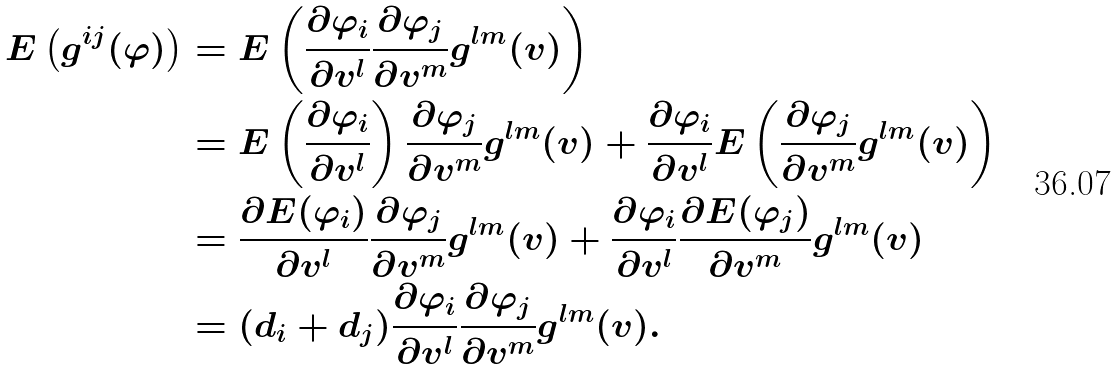Convert formula to latex. <formula><loc_0><loc_0><loc_500><loc_500>E \left ( g ^ { i j } ( \varphi ) \right ) & = E \left ( \frac { \partial \varphi _ { i } } { \partial v ^ { l } } \frac { \partial \varphi _ { j } } { \partial v ^ { m } } g ^ { l m } ( v ) \right ) \\ & = E \left ( \frac { \partial \varphi _ { i } } { \partial v ^ { l } } \right ) \frac { \partial \varphi _ { j } } { \partial v ^ { m } } g ^ { l m } ( v ) + \frac { \partial \varphi _ { i } } { \partial v ^ { l } } E \left ( \frac { \partial \varphi _ { j } } { \partial v ^ { m } } g ^ { l m } ( v ) \right ) \\ & = \frac { \partial E ( \varphi _ { i } ) } { \partial v ^ { l } } \frac { \partial \varphi _ { j } } { \partial v ^ { m } } g ^ { l m } ( v ) + \frac { \partial \varphi _ { i } } { \partial v ^ { l } } \frac { \partial E ( \varphi _ { j } ) } { \partial v ^ { m } } g ^ { l m } ( v ) \\ & = ( d _ { i } + d _ { j } ) \frac { \partial \varphi _ { i } } { \partial v ^ { l } } \frac { \partial \varphi _ { j } } { \partial v ^ { m } } g ^ { l m } ( v ) .</formula> 